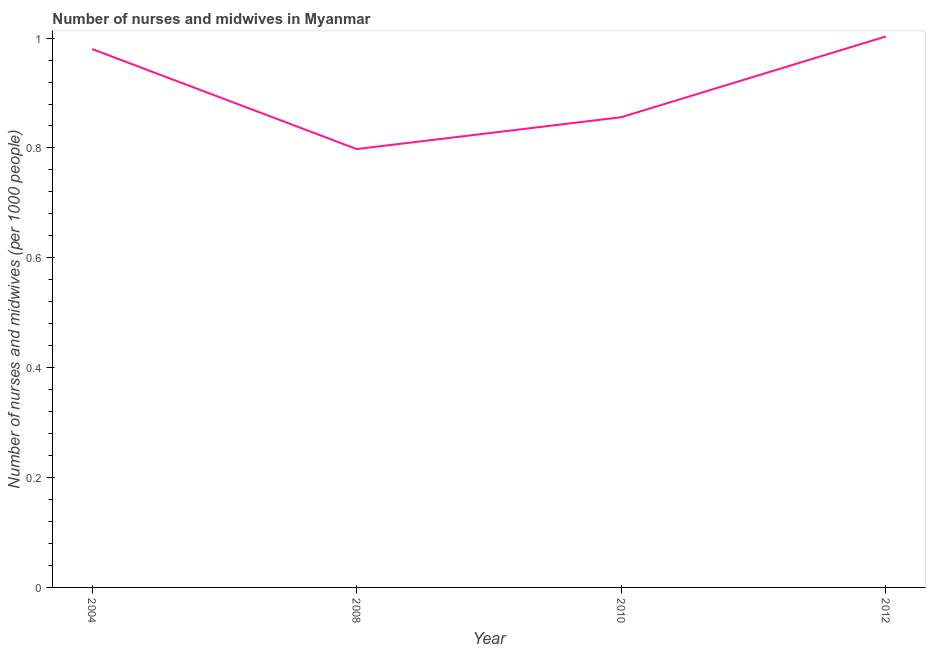What is the number of nurses and midwives in 2008?
Offer a very short reply. 0.8. Across all years, what is the maximum number of nurses and midwives?
Make the answer very short. 1. Across all years, what is the minimum number of nurses and midwives?
Give a very brief answer. 0.8. What is the sum of the number of nurses and midwives?
Provide a succinct answer. 3.64. What is the difference between the number of nurses and midwives in 2008 and 2010?
Provide a short and direct response. -0.06. What is the average number of nurses and midwives per year?
Offer a very short reply. 0.91. What is the median number of nurses and midwives?
Your answer should be compact. 0.92. In how many years, is the number of nurses and midwives greater than 0.08 ?
Your answer should be very brief. 4. Do a majority of the years between 2012 and 2008 (inclusive) have number of nurses and midwives greater than 0.48000000000000004 ?
Ensure brevity in your answer.  No. What is the ratio of the number of nurses and midwives in 2008 to that in 2012?
Offer a very short reply. 0.8. Is the number of nurses and midwives in 2008 less than that in 2012?
Provide a succinct answer. Yes. Is the difference between the number of nurses and midwives in 2008 and 2010 greater than the difference between any two years?
Keep it short and to the point. No. What is the difference between the highest and the second highest number of nurses and midwives?
Keep it short and to the point. 0.02. Is the sum of the number of nurses and midwives in 2008 and 2010 greater than the maximum number of nurses and midwives across all years?
Provide a short and direct response. Yes. What is the difference between the highest and the lowest number of nurses and midwives?
Offer a terse response. 0.2. Does the number of nurses and midwives monotonically increase over the years?
Keep it short and to the point. No. What is the title of the graph?
Your answer should be compact. Number of nurses and midwives in Myanmar. What is the label or title of the X-axis?
Your answer should be very brief. Year. What is the label or title of the Y-axis?
Offer a very short reply. Number of nurses and midwives (per 1000 people). What is the Number of nurses and midwives (per 1000 people) in 2004?
Provide a short and direct response. 0.98. What is the Number of nurses and midwives (per 1000 people) of 2008?
Ensure brevity in your answer.  0.8. What is the Number of nurses and midwives (per 1000 people) of 2010?
Your response must be concise. 0.86. What is the difference between the Number of nurses and midwives (per 1000 people) in 2004 and 2008?
Your response must be concise. 0.18. What is the difference between the Number of nurses and midwives (per 1000 people) in 2004 and 2010?
Your answer should be compact. 0.12. What is the difference between the Number of nurses and midwives (per 1000 people) in 2004 and 2012?
Your answer should be very brief. -0.02. What is the difference between the Number of nurses and midwives (per 1000 people) in 2008 and 2010?
Keep it short and to the point. -0.06. What is the difference between the Number of nurses and midwives (per 1000 people) in 2008 and 2012?
Offer a terse response. -0.2. What is the difference between the Number of nurses and midwives (per 1000 people) in 2010 and 2012?
Your answer should be very brief. -0.15. What is the ratio of the Number of nurses and midwives (per 1000 people) in 2004 to that in 2008?
Provide a succinct answer. 1.23. What is the ratio of the Number of nurses and midwives (per 1000 people) in 2004 to that in 2010?
Your answer should be very brief. 1.15. What is the ratio of the Number of nurses and midwives (per 1000 people) in 2004 to that in 2012?
Your answer should be very brief. 0.98. What is the ratio of the Number of nurses and midwives (per 1000 people) in 2008 to that in 2010?
Make the answer very short. 0.93. What is the ratio of the Number of nurses and midwives (per 1000 people) in 2008 to that in 2012?
Offer a very short reply. 0.8. What is the ratio of the Number of nurses and midwives (per 1000 people) in 2010 to that in 2012?
Your answer should be very brief. 0.85. 